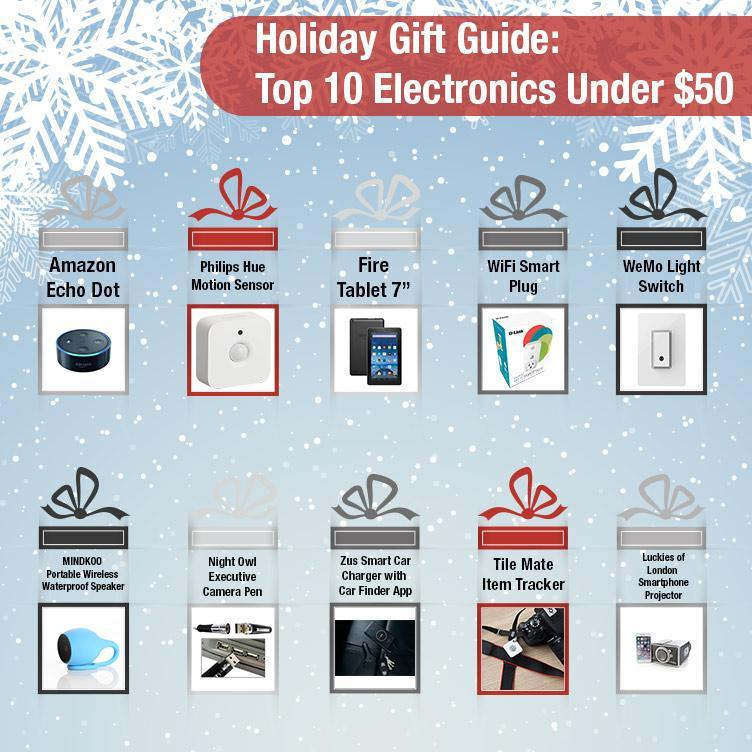Which products are shown inside a red gift wrap?
Answer the question with a short phrase. Motion Sensor, Item Tracker Which product is showcased in a black gift package? WeMo Light Switch What is the brand name of the sensing device shown in the image, Amazon, Philips, or WeMo? Philips 